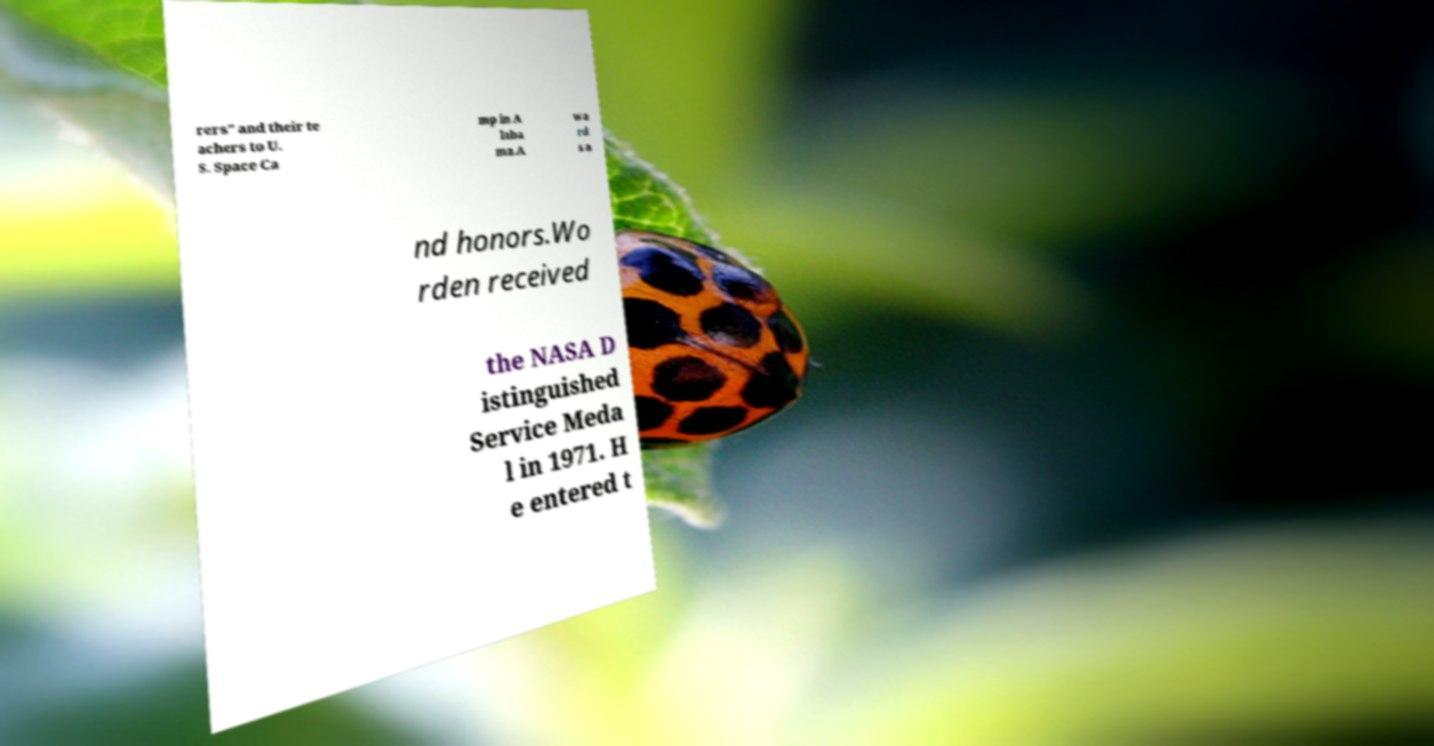Please identify and transcribe the text found in this image. rers" and their te achers to U. S. Space Ca mp in A laba ma.A wa rd s a nd honors.Wo rden received the NASA D istinguished Service Meda l in 1971. H e entered t 